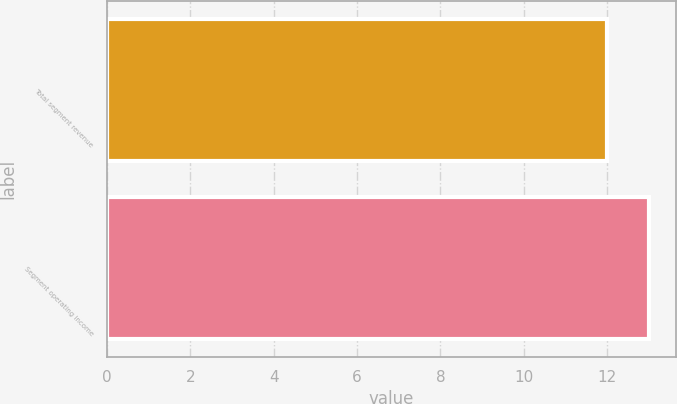Convert chart to OTSL. <chart><loc_0><loc_0><loc_500><loc_500><bar_chart><fcel>Total segment revenue<fcel>Segment operating income<nl><fcel>12<fcel>13<nl></chart> 